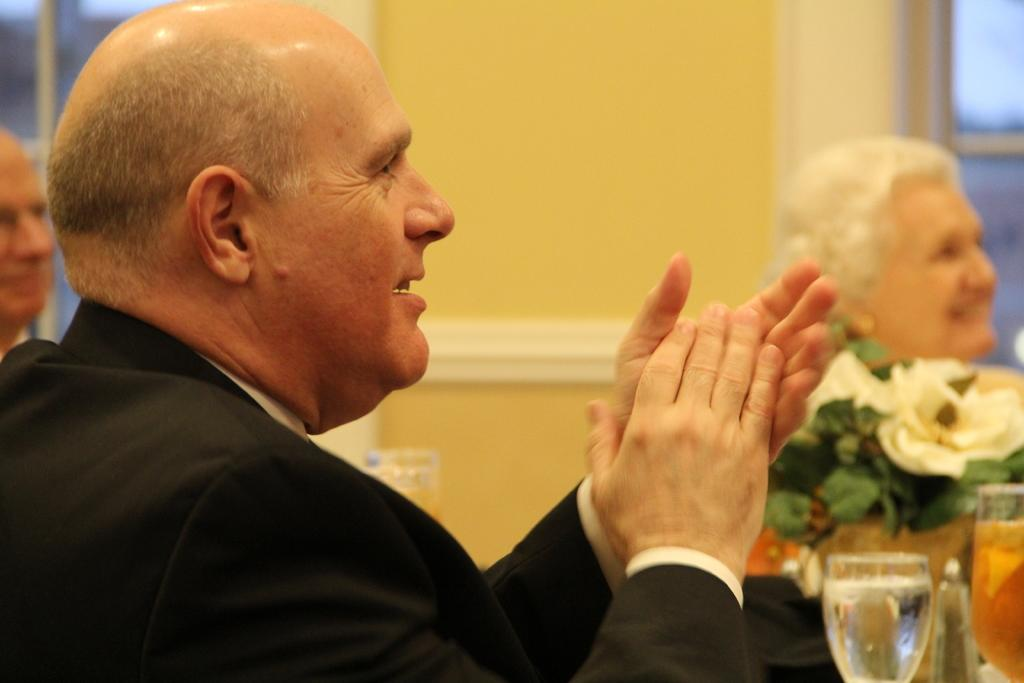Who or what can be seen in the image? There are people in the image. What can be found on the right side of the image? There are objects on the right side of the image. What is visible in the background of the image? There is a wall visible in the background of the image. Is there a spot of steam visible near the people in the image? There is no steam present in the image. 